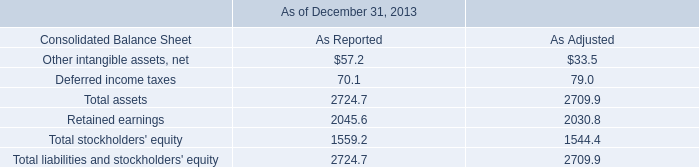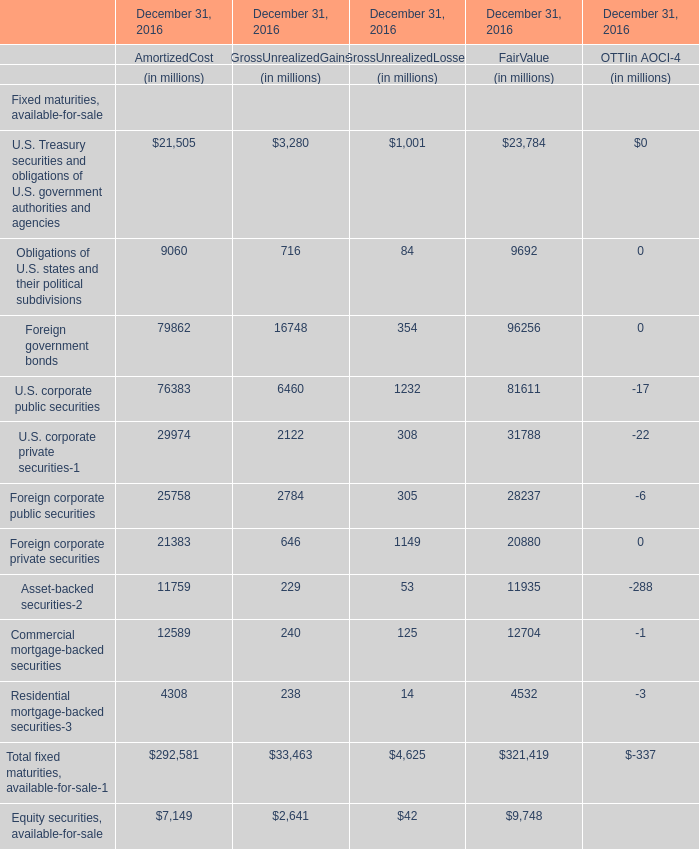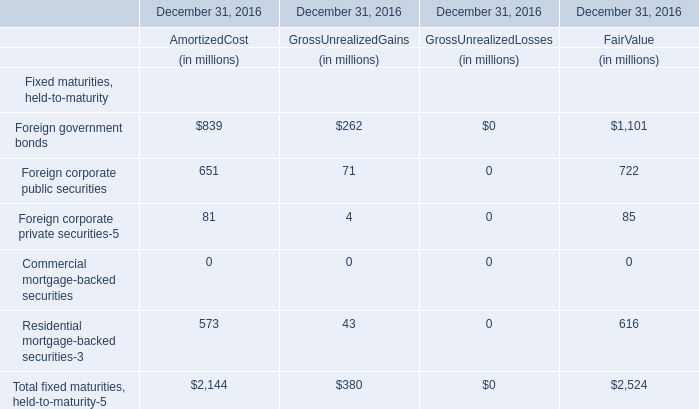The total amount of which section ranks first in AmortizedCost ? 
Answer: Total fixed maturities, available-for-sale-1. 